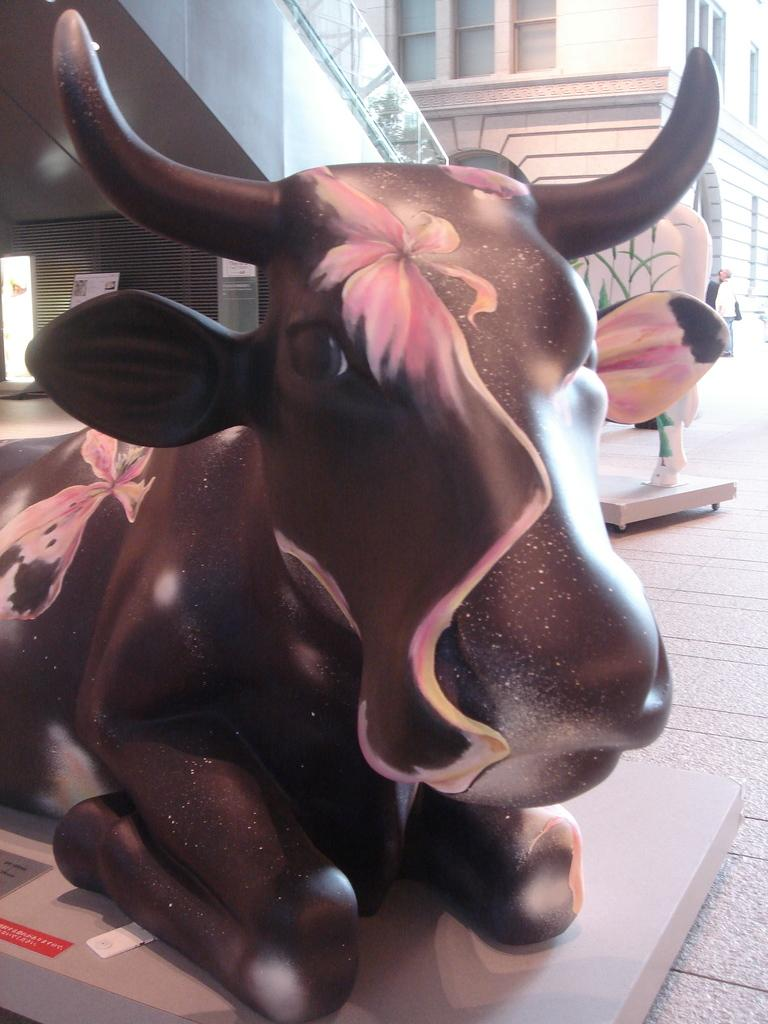What is the main subject in the image? There is a bull statue in the image. Where is the bull statue located in the image? The bull statue is in the middle of the image. What can be seen in the background of the image? There is a building in the background of the image. How many eggs are being used to clean the soap in the image? There are no eggs or soap present in the image; it features a bull statue and a building in the background. 